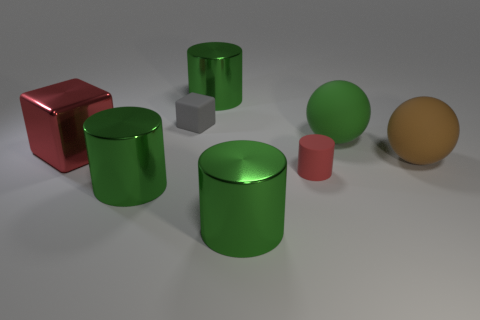How many green cylinders must be subtracted to get 1 green cylinders? 2 Subtract all small red cylinders. How many cylinders are left? 3 Add 1 small matte objects. How many objects exist? 9 Subtract all red cylinders. How many cylinders are left? 3 Add 3 tiny gray shiny things. How many tiny gray shiny things exist? 3 Subtract 0 blue cylinders. How many objects are left? 8 Subtract all cubes. How many objects are left? 6 Subtract 1 spheres. How many spheres are left? 1 Subtract all purple balls. Subtract all brown cylinders. How many balls are left? 2 Subtract all purple blocks. How many gray cylinders are left? 0 